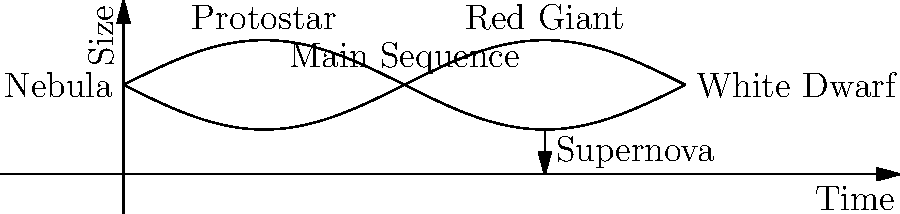In the life cycle of a star, which stage represents the most dramatic and visually striking transformation, potentially serving as a metaphor for a character's pivotal moment in a narrative? To answer this question, let's consider the stages of a star's life cycle and their potential metaphorical significance:

1. Nebula: The birth of a star, representing potential and beginnings.
2. Protostar: Early formation, symbolizing growth and development.
3. Main Sequence: Stable period, akin to a character's normal life.
4. Red Giant: Expansion phase, could represent a character's growth or challenges.
5. White Dwarf: Final stage for smaller stars, symbolizing a quiet ending.
6. Supernova: Explosive end for massive stars, representing a dramatic transformation.

Among these stages, the supernova stands out as the most dramatic and visually striking transformation. It involves:

1. A massive explosion visible across vast distances
2. The release of enormous amounts of energy
3. The creation of new elements
4. The potential formation of a black hole or neutron star

In narrative terms, a supernova could metaphorically represent:
- A character's moment of extreme change or revelation
- A climactic event that reshapes the story's universe
- A profound transformation that affects everything around it

The supernova's ability to create new elements while destroying the original star also provides a powerful metaphor for rebirth and transformation through destruction.
Answer: Supernova 